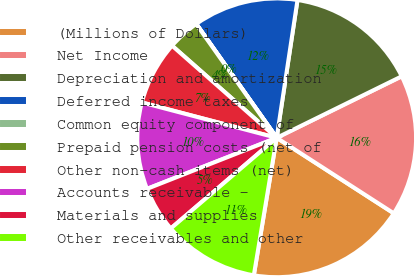<chart> <loc_0><loc_0><loc_500><loc_500><pie_chart><fcel>(Millions of Dollars)<fcel>Net Income<fcel>Depreciation and amortization<fcel>Deferred income taxes<fcel>Common equity component of<fcel>Prepaid pension costs (net of<fcel>Other non-cash items (net)<fcel>Accounts receivable -<fcel>Materials and supplies<fcel>Other receivables and other<nl><fcel>18.51%<fcel>16.39%<fcel>15.34%<fcel>12.17%<fcel>0.02%<fcel>3.71%<fcel>7.41%<fcel>10.05%<fcel>5.3%<fcel>11.11%<nl></chart> 